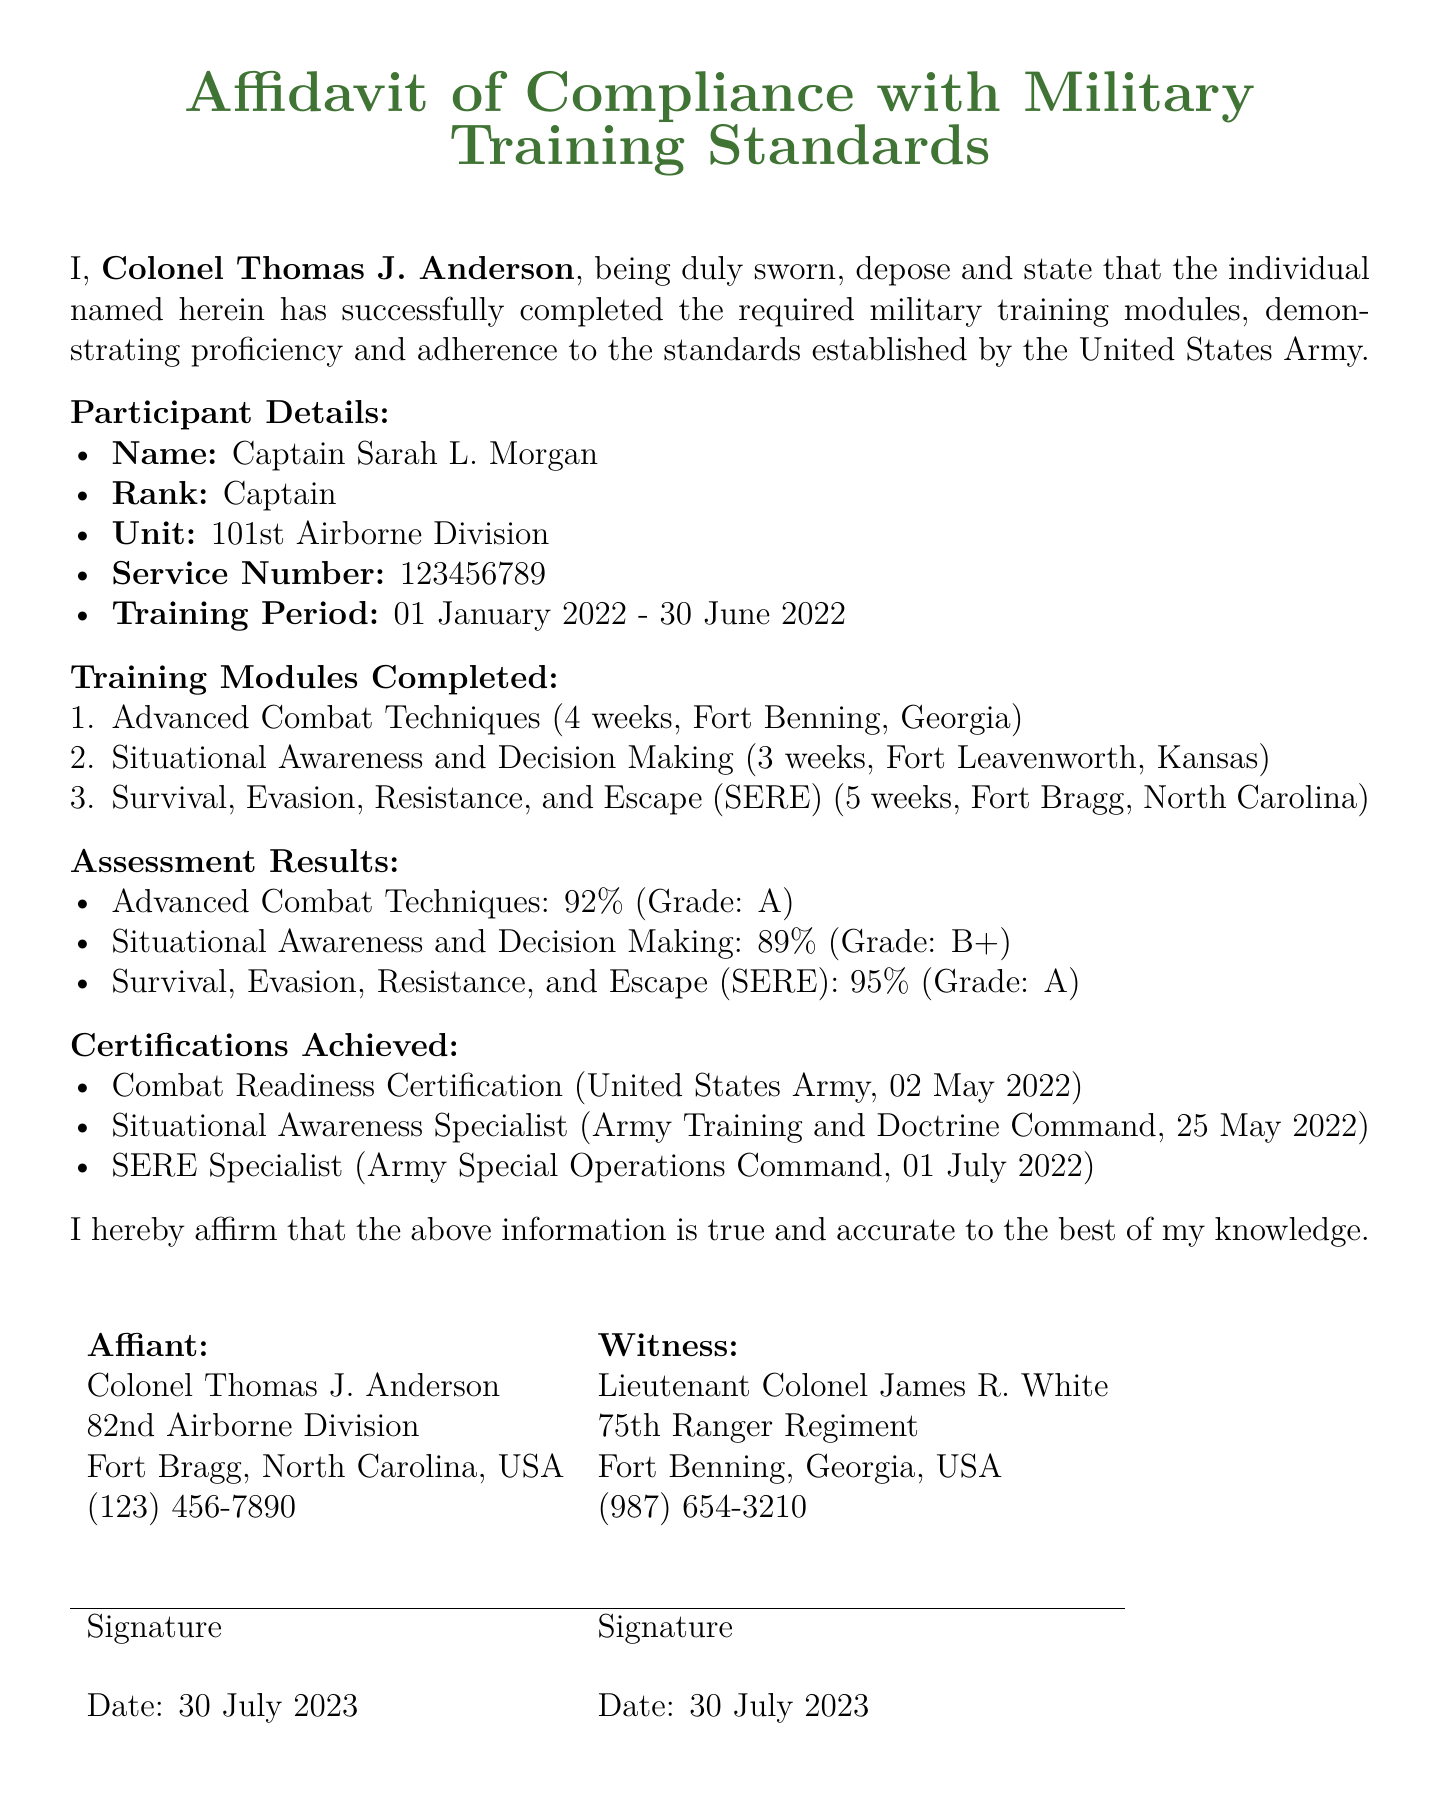What is the name of the participant? The participant's name is clearly stated under Participant Details.
Answer: Captain Sarah L. Morgan What is the service number of the participant? The service number is presented under Participant Details, which specifies the participant's identification.
Answer: 123456789 How long did the training period last? The training period is defined in the document, indicating the dates involved.
Answer: 01 January 2022 - 30 June 2022 What was the grade received for the SERE training? The grade for the SERE training is mentioned under Assessment Results, showing the performance level.
Answer: A Which unit does Captain Sarah L. Morgan belong to? The unit information is listed under Participant Details, describing the participant's affiliation.
Answer: 101st Airborne Division What is the date of the Combat Readiness Certification? The certification date is given under Certifications Achieved, indicating when it was obtained.
Answer: 02 May 2022 How many weeks did the Advanced Combat Techniques training last? The duration of the training module is specified under Training Modules Completed, showing the time commitment.
Answer: 4 weeks Who witnessed the affidavit? The witness's name is listed in the affidavit section, indicating who confirmed the document.
Answer: Lieutenant Colonel James R. White What was the assessment result for Situational Awareness and Decision Making? The assessment result for this module is found under Assessment Results, providing details on performance.
Answer: 89% 